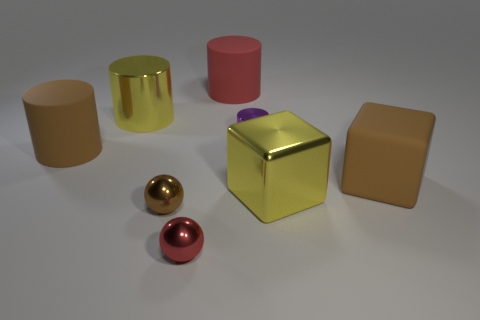There is a shiny cylinder that is the same color as the shiny cube; what size is it?
Provide a short and direct response. Large. How many other things are there of the same color as the large rubber cube?
Offer a terse response. 2. Is the number of purple cylinders that are in front of the small red sphere less than the number of red cylinders?
Give a very brief answer. Yes. Is there another cylinder that has the same size as the yellow metallic cylinder?
Keep it short and to the point. Yes. Does the large metal block have the same color as the large cylinder to the right of the small red sphere?
Offer a terse response. No. How many cylinders are on the right side of the large brown object that is behind the brown rubber cube?
Provide a short and direct response. 3. What color is the metallic sphere behind the red object in front of the large brown rubber cylinder?
Give a very brief answer. Brown. What material is the big object that is right of the big red rubber cylinder and behind the yellow block?
Provide a succinct answer. Rubber. Is there a tiny red thing of the same shape as the purple metal object?
Provide a short and direct response. No. Is the shape of the yellow metallic thing that is to the left of the brown metal ball the same as  the small purple metallic object?
Your answer should be very brief. Yes. 